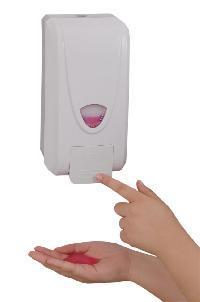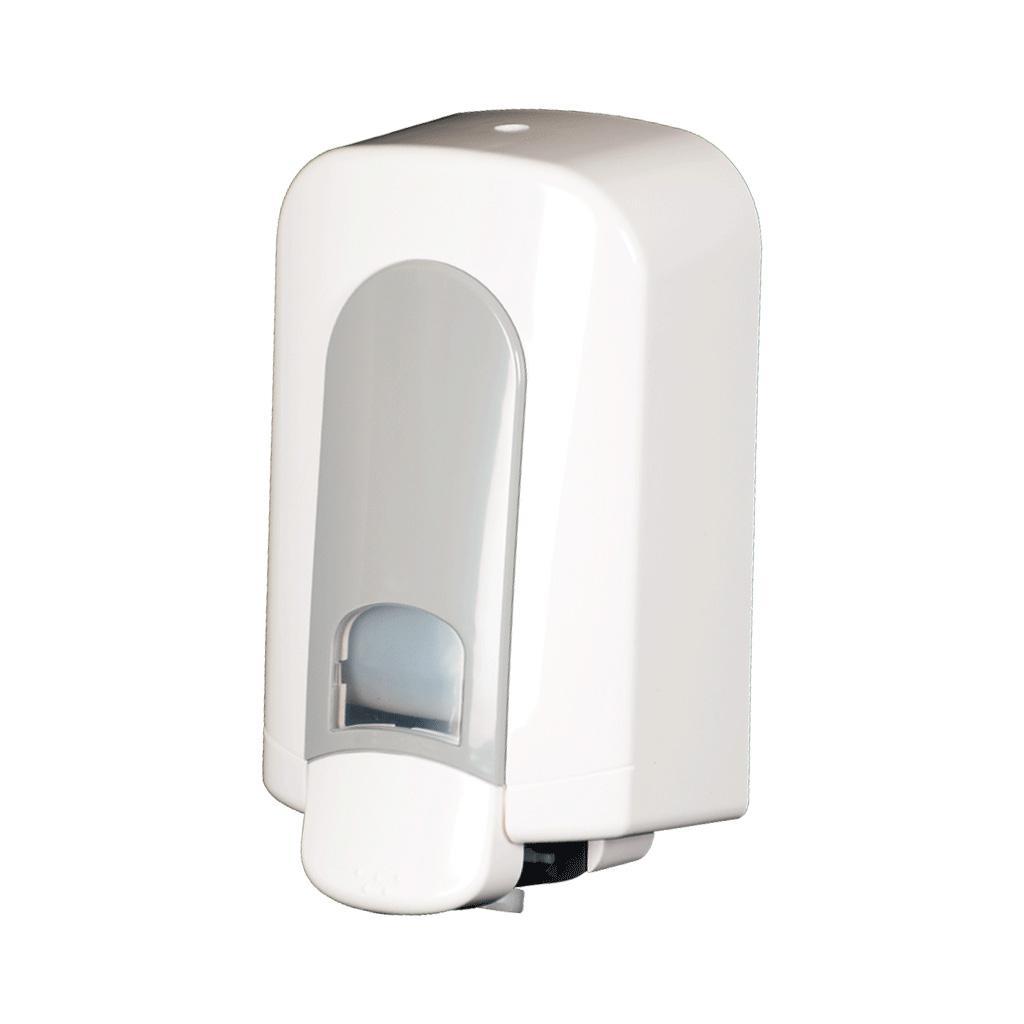The first image is the image on the left, the second image is the image on the right. Assess this claim about the two images: "One soap dispenser has a flat bottom and can be set on a counter.". Correct or not? Answer yes or no. No. 